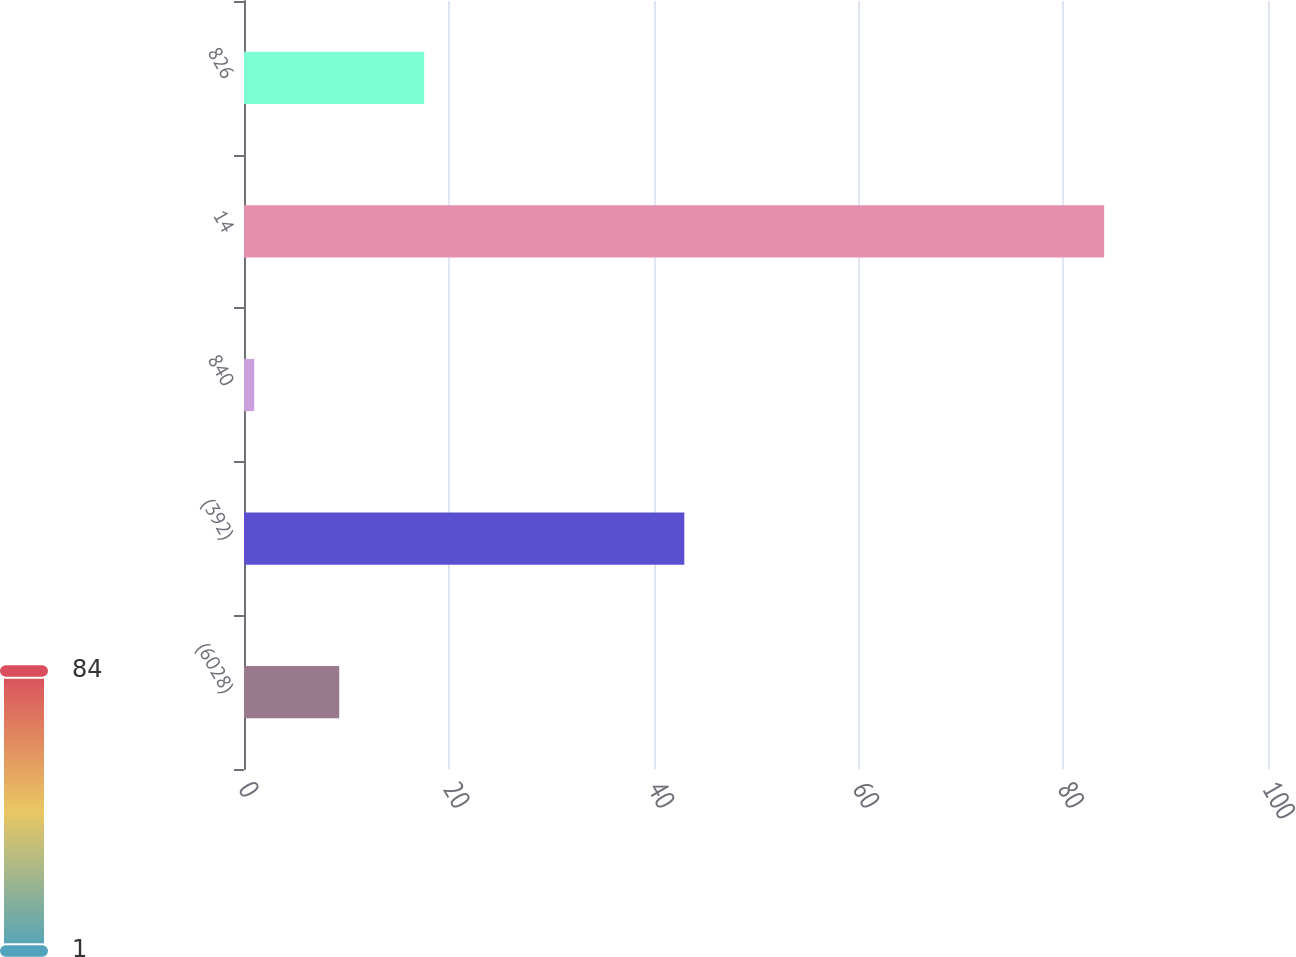<chart> <loc_0><loc_0><loc_500><loc_500><bar_chart><fcel>(6028)<fcel>(392)<fcel>840<fcel>14<fcel>826<nl><fcel>9.3<fcel>43<fcel>1<fcel>84<fcel>17.6<nl></chart> 